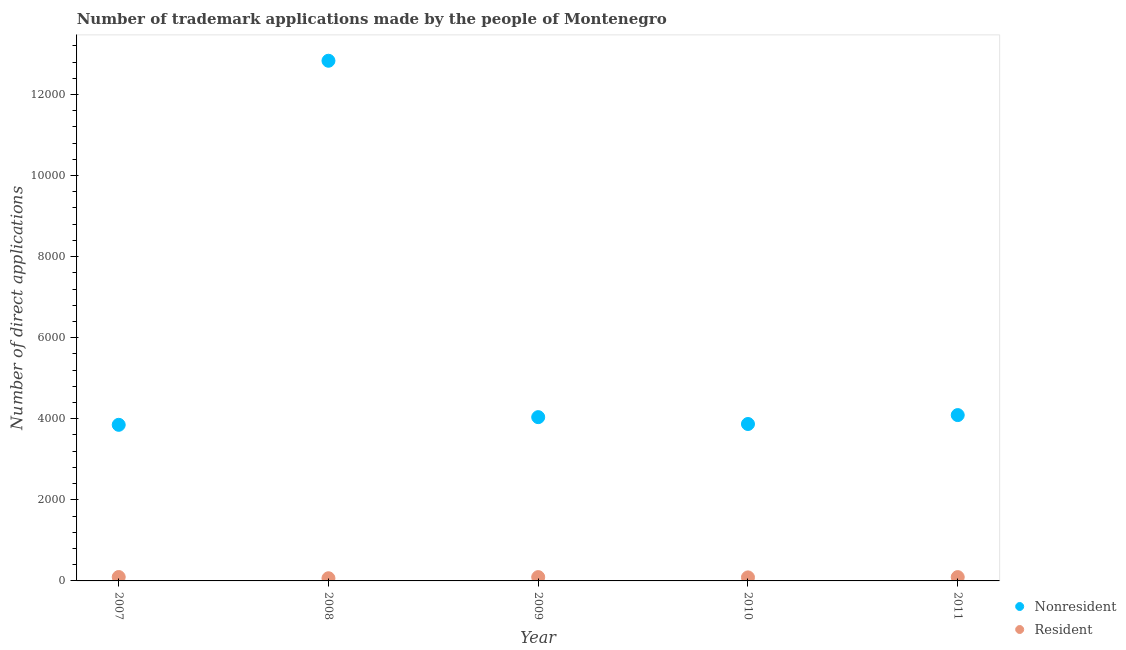What is the number of trademark applications made by residents in 2011?
Provide a short and direct response. 94. Across all years, what is the maximum number of trademark applications made by residents?
Ensure brevity in your answer.  96. Across all years, what is the minimum number of trademark applications made by non residents?
Make the answer very short. 3851. In which year was the number of trademark applications made by residents maximum?
Offer a very short reply. 2007. What is the total number of trademark applications made by residents in the graph?
Offer a terse response. 437. What is the difference between the number of trademark applications made by non residents in 2007 and that in 2011?
Your answer should be compact. -240. What is the difference between the number of trademark applications made by residents in 2008 and the number of trademark applications made by non residents in 2009?
Make the answer very short. -3974. What is the average number of trademark applications made by non residents per year?
Ensure brevity in your answer.  5737. In the year 2008, what is the difference between the number of trademark applications made by residents and number of trademark applications made by non residents?
Keep it short and to the point. -1.28e+04. In how many years, is the number of trademark applications made by non residents greater than 10800?
Keep it short and to the point. 1. What is the ratio of the number of trademark applications made by non residents in 2009 to that in 2010?
Offer a very short reply. 1.04. Is the number of trademark applications made by non residents in 2008 less than that in 2009?
Ensure brevity in your answer.  No. Is the difference between the number of trademark applications made by non residents in 2008 and 2010 greater than the difference between the number of trademark applications made by residents in 2008 and 2010?
Offer a very short reply. Yes. What is the difference between the highest and the second highest number of trademark applications made by non residents?
Offer a terse response. 8741. What is the difference between the highest and the lowest number of trademark applications made by non residents?
Provide a short and direct response. 8981. In how many years, is the number of trademark applications made by non residents greater than the average number of trademark applications made by non residents taken over all years?
Provide a short and direct response. 1. Is the number of trademark applications made by residents strictly less than the number of trademark applications made by non residents over the years?
Offer a terse response. Yes. How many dotlines are there?
Offer a terse response. 2. What is the difference between two consecutive major ticks on the Y-axis?
Provide a succinct answer. 2000. Are the values on the major ticks of Y-axis written in scientific E-notation?
Your answer should be very brief. No. Does the graph contain grids?
Your answer should be very brief. No. What is the title of the graph?
Your answer should be very brief. Number of trademark applications made by the people of Montenegro. Does "Excluding technical cooperation" appear as one of the legend labels in the graph?
Provide a succinct answer. No. What is the label or title of the Y-axis?
Make the answer very short. Number of direct applications. What is the Number of direct applications of Nonresident in 2007?
Give a very brief answer. 3851. What is the Number of direct applications of Resident in 2007?
Keep it short and to the point. 96. What is the Number of direct applications in Nonresident in 2008?
Offer a terse response. 1.28e+04. What is the Number of direct applications of Nonresident in 2009?
Keep it short and to the point. 4040. What is the Number of direct applications of Resident in 2009?
Keep it short and to the point. 94. What is the Number of direct applications in Nonresident in 2010?
Provide a succinct answer. 3871. What is the Number of direct applications in Resident in 2010?
Ensure brevity in your answer.  87. What is the Number of direct applications in Nonresident in 2011?
Make the answer very short. 4091. What is the Number of direct applications of Resident in 2011?
Provide a succinct answer. 94. Across all years, what is the maximum Number of direct applications in Nonresident?
Your response must be concise. 1.28e+04. Across all years, what is the maximum Number of direct applications in Resident?
Make the answer very short. 96. Across all years, what is the minimum Number of direct applications in Nonresident?
Provide a short and direct response. 3851. Across all years, what is the minimum Number of direct applications of Resident?
Ensure brevity in your answer.  66. What is the total Number of direct applications of Nonresident in the graph?
Provide a short and direct response. 2.87e+04. What is the total Number of direct applications in Resident in the graph?
Provide a short and direct response. 437. What is the difference between the Number of direct applications of Nonresident in 2007 and that in 2008?
Provide a succinct answer. -8981. What is the difference between the Number of direct applications in Resident in 2007 and that in 2008?
Your answer should be compact. 30. What is the difference between the Number of direct applications in Nonresident in 2007 and that in 2009?
Provide a short and direct response. -189. What is the difference between the Number of direct applications in Resident in 2007 and that in 2010?
Your answer should be compact. 9. What is the difference between the Number of direct applications in Nonresident in 2007 and that in 2011?
Give a very brief answer. -240. What is the difference between the Number of direct applications in Resident in 2007 and that in 2011?
Keep it short and to the point. 2. What is the difference between the Number of direct applications in Nonresident in 2008 and that in 2009?
Your answer should be very brief. 8792. What is the difference between the Number of direct applications of Nonresident in 2008 and that in 2010?
Offer a terse response. 8961. What is the difference between the Number of direct applications in Resident in 2008 and that in 2010?
Ensure brevity in your answer.  -21. What is the difference between the Number of direct applications in Nonresident in 2008 and that in 2011?
Your response must be concise. 8741. What is the difference between the Number of direct applications of Resident in 2008 and that in 2011?
Ensure brevity in your answer.  -28. What is the difference between the Number of direct applications of Nonresident in 2009 and that in 2010?
Provide a succinct answer. 169. What is the difference between the Number of direct applications of Resident in 2009 and that in 2010?
Ensure brevity in your answer.  7. What is the difference between the Number of direct applications of Nonresident in 2009 and that in 2011?
Your answer should be compact. -51. What is the difference between the Number of direct applications of Nonresident in 2010 and that in 2011?
Your answer should be compact. -220. What is the difference between the Number of direct applications in Resident in 2010 and that in 2011?
Provide a short and direct response. -7. What is the difference between the Number of direct applications of Nonresident in 2007 and the Number of direct applications of Resident in 2008?
Give a very brief answer. 3785. What is the difference between the Number of direct applications of Nonresident in 2007 and the Number of direct applications of Resident in 2009?
Provide a succinct answer. 3757. What is the difference between the Number of direct applications in Nonresident in 2007 and the Number of direct applications in Resident in 2010?
Make the answer very short. 3764. What is the difference between the Number of direct applications in Nonresident in 2007 and the Number of direct applications in Resident in 2011?
Your answer should be very brief. 3757. What is the difference between the Number of direct applications in Nonresident in 2008 and the Number of direct applications in Resident in 2009?
Provide a succinct answer. 1.27e+04. What is the difference between the Number of direct applications in Nonresident in 2008 and the Number of direct applications in Resident in 2010?
Your answer should be very brief. 1.27e+04. What is the difference between the Number of direct applications of Nonresident in 2008 and the Number of direct applications of Resident in 2011?
Offer a terse response. 1.27e+04. What is the difference between the Number of direct applications in Nonresident in 2009 and the Number of direct applications in Resident in 2010?
Make the answer very short. 3953. What is the difference between the Number of direct applications in Nonresident in 2009 and the Number of direct applications in Resident in 2011?
Make the answer very short. 3946. What is the difference between the Number of direct applications in Nonresident in 2010 and the Number of direct applications in Resident in 2011?
Make the answer very short. 3777. What is the average Number of direct applications of Nonresident per year?
Offer a terse response. 5737. What is the average Number of direct applications of Resident per year?
Give a very brief answer. 87.4. In the year 2007, what is the difference between the Number of direct applications of Nonresident and Number of direct applications of Resident?
Give a very brief answer. 3755. In the year 2008, what is the difference between the Number of direct applications of Nonresident and Number of direct applications of Resident?
Give a very brief answer. 1.28e+04. In the year 2009, what is the difference between the Number of direct applications of Nonresident and Number of direct applications of Resident?
Your answer should be compact. 3946. In the year 2010, what is the difference between the Number of direct applications of Nonresident and Number of direct applications of Resident?
Your answer should be very brief. 3784. In the year 2011, what is the difference between the Number of direct applications in Nonresident and Number of direct applications in Resident?
Make the answer very short. 3997. What is the ratio of the Number of direct applications of Nonresident in 2007 to that in 2008?
Make the answer very short. 0.3. What is the ratio of the Number of direct applications in Resident in 2007 to that in 2008?
Give a very brief answer. 1.45. What is the ratio of the Number of direct applications of Nonresident in 2007 to that in 2009?
Your answer should be compact. 0.95. What is the ratio of the Number of direct applications of Resident in 2007 to that in 2009?
Provide a succinct answer. 1.02. What is the ratio of the Number of direct applications of Resident in 2007 to that in 2010?
Ensure brevity in your answer.  1.1. What is the ratio of the Number of direct applications of Nonresident in 2007 to that in 2011?
Your response must be concise. 0.94. What is the ratio of the Number of direct applications of Resident in 2007 to that in 2011?
Provide a succinct answer. 1.02. What is the ratio of the Number of direct applications of Nonresident in 2008 to that in 2009?
Ensure brevity in your answer.  3.18. What is the ratio of the Number of direct applications of Resident in 2008 to that in 2009?
Offer a terse response. 0.7. What is the ratio of the Number of direct applications in Nonresident in 2008 to that in 2010?
Your answer should be very brief. 3.31. What is the ratio of the Number of direct applications of Resident in 2008 to that in 2010?
Provide a short and direct response. 0.76. What is the ratio of the Number of direct applications in Nonresident in 2008 to that in 2011?
Offer a very short reply. 3.14. What is the ratio of the Number of direct applications in Resident in 2008 to that in 2011?
Keep it short and to the point. 0.7. What is the ratio of the Number of direct applications in Nonresident in 2009 to that in 2010?
Keep it short and to the point. 1.04. What is the ratio of the Number of direct applications of Resident in 2009 to that in 2010?
Your answer should be very brief. 1.08. What is the ratio of the Number of direct applications of Nonresident in 2009 to that in 2011?
Provide a succinct answer. 0.99. What is the ratio of the Number of direct applications of Resident in 2009 to that in 2011?
Keep it short and to the point. 1. What is the ratio of the Number of direct applications of Nonresident in 2010 to that in 2011?
Your answer should be very brief. 0.95. What is the ratio of the Number of direct applications in Resident in 2010 to that in 2011?
Offer a terse response. 0.93. What is the difference between the highest and the second highest Number of direct applications of Nonresident?
Provide a short and direct response. 8741. What is the difference between the highest and the second highest Number of direct applications of Resident?
Your answer should be very brief. 2. What is the difference between the highest and the lowest Number of direct applications in Nonresident?
Your response must be concise. 8981. 